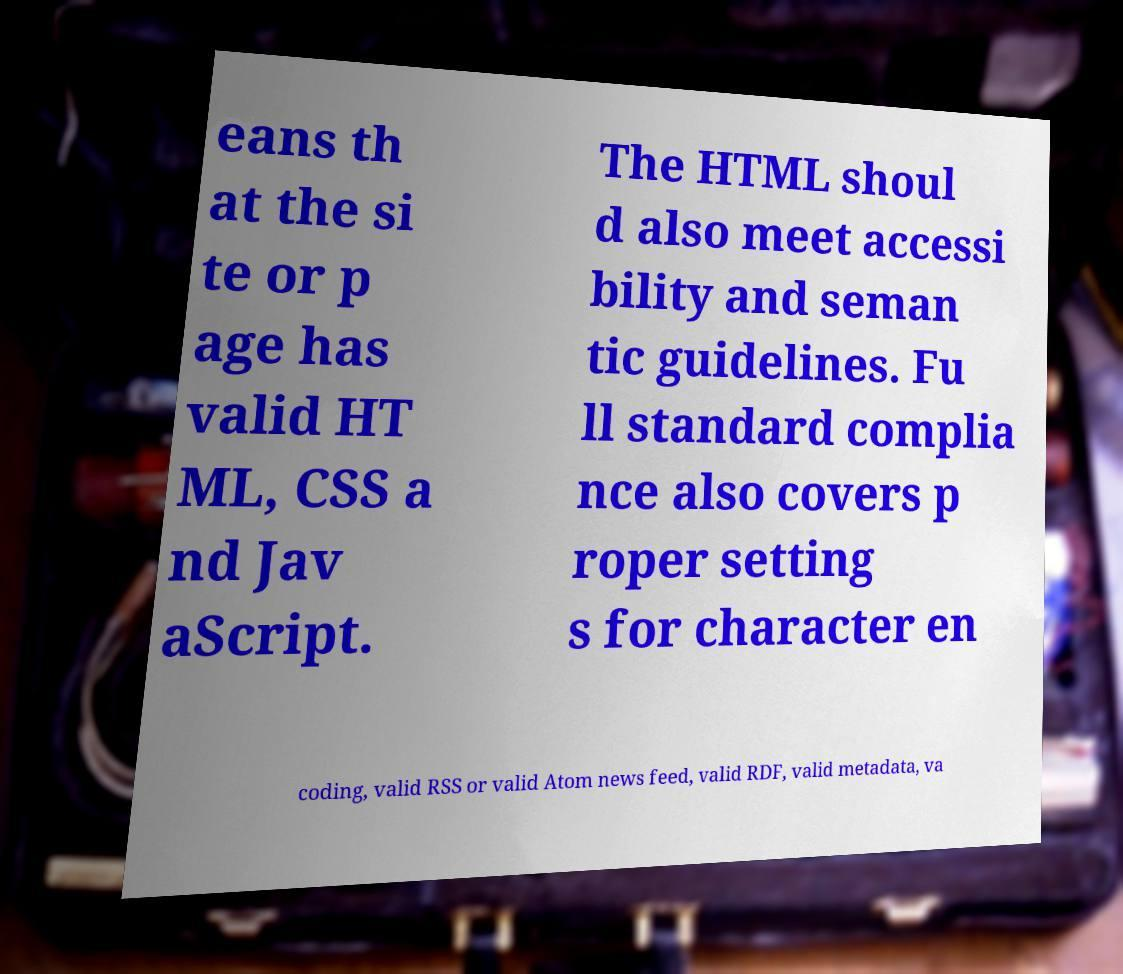For documentation purposes, I need the text within this image transcribed. Could you provide that? eans th at the si te or p age has valid HT ML, CSS a nd Jav aScript. The HTML shoul d also meet accessi bility and seman tic guidelines. Fu ll standard complia nce also covers p roper setting s for character en coding, valid RSS or valid Atom news feed, valid RDF, valid metadata, va 